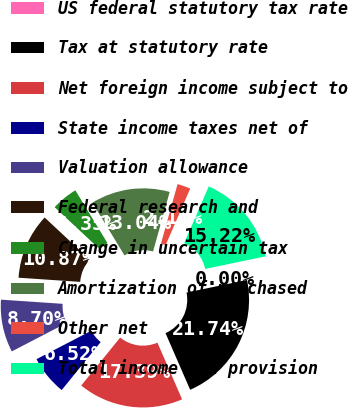<chart> <loc_0><loc_0><loc_500><loc_500><pie_chart><fcel>US federal statutory tax rate<fcel>Tax at statutory rate<fcel>Net foreign income subject to<fcel>State income taxes net of<fcel>Valuation allowance<fcel>Federal research and<fcel>Change in uncertain tax<fcel>Amortization of purchased<fcel>Other net<fcel>Total income tax provision<nl><fcel>0.0%<fcel>21.74%<fcel>17.39%<fcel>6.52%<fcel>8.7%<fcel>10.87%<fcel>4.35%<fcel>13.04%<fcel>2.18%<fcel>15.22%<nl></chart> 